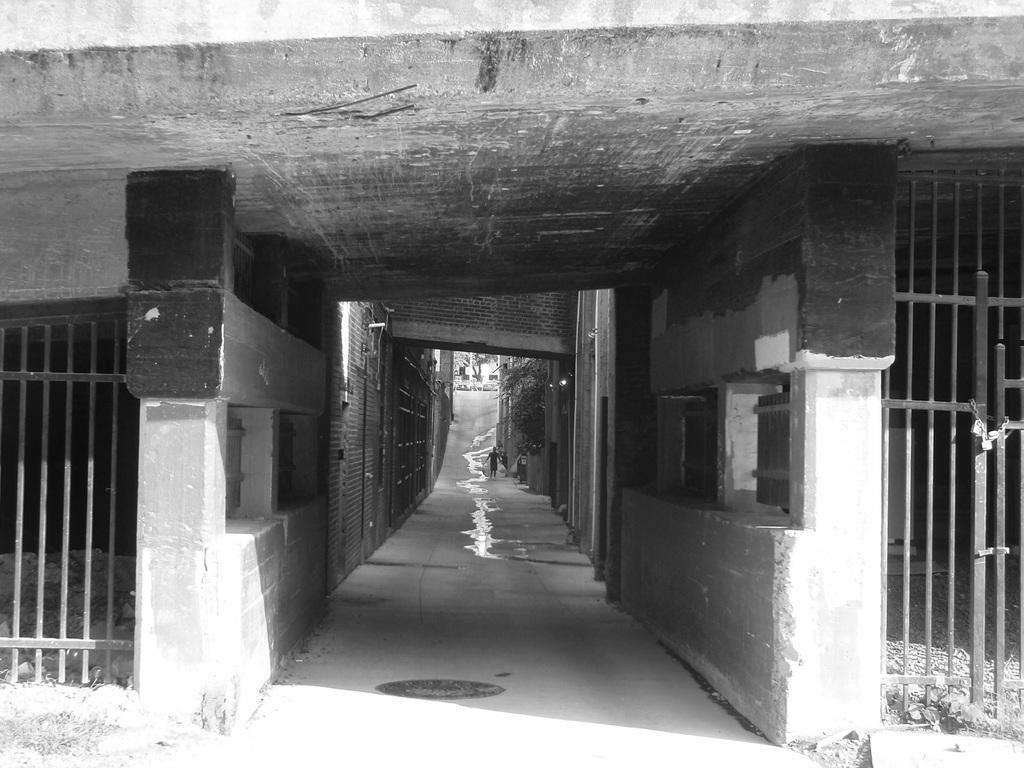Describe this image in one or two sentences. In this image we see there is a narrow street and on the right side there is a gate made of iron. 